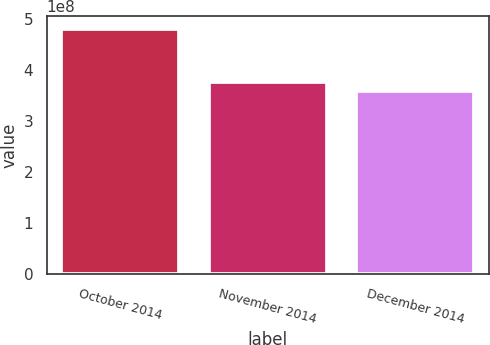Convert chart to OTSL. <chart><loc_0><loc_0><loc_500><loc_500><bar_chart><fcel>October 2014<fcel>November 2014<fcel>December 2014<nl><fcel>4.81745e+08<fcel>3.77928e+08<fcel>3.60247e+08<nl></chart> 